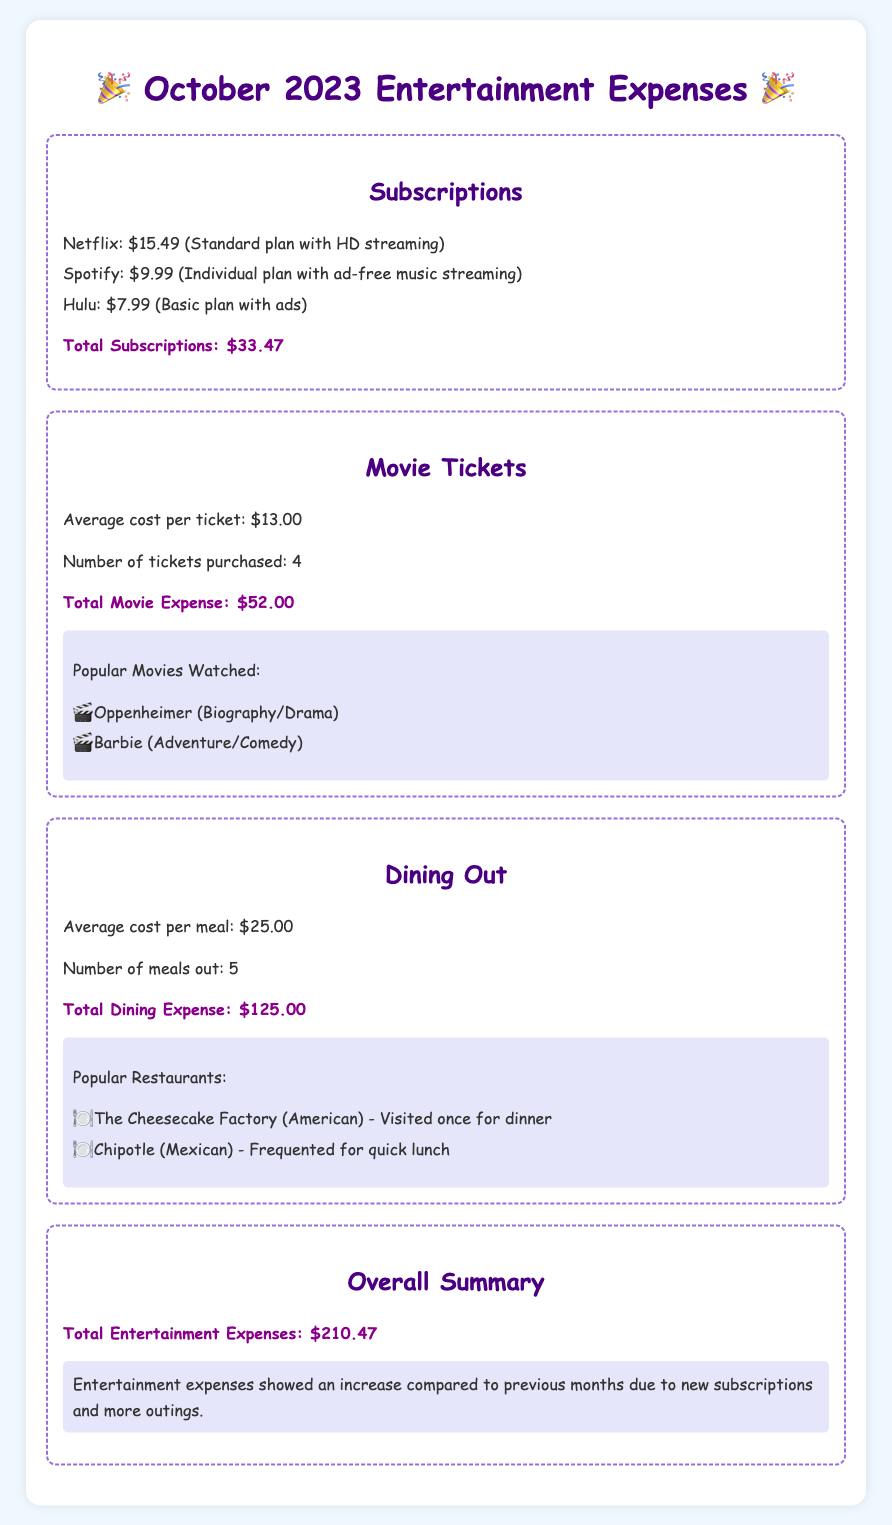What is the total amount spent on subscriptions? The total amount for subscriptions is listed in the document and is $33.47.
Answer: $33.47 How many movie tickets were purchased? The document states that 4 movie tickets were purchased.
Answer: 4 What was the cost of a meal on average? The average cost per meal is specifically mentioned in the dining section as $25.00.
Answer: $25.00 What are the popular movies watched? The document lists "Oppenheimer" and "Barbie" as the popular movies watched.
Answer: Oppenheimer and Barbie What is the total entertainment expense for October 2023? The overall summary section provides the total entertainment expenses, which is $210.47.
Answer: $210.47 How many meals were eaten out? According to the dining section, 5 meals were eaten out.
Answer: 5 Which subscription is the most expensive? The document lists Netflix as the most expensive subscription at $15.49.
Answer: Netflix What type of restaurant is Chipotle? The document categorizes Chipotle as a Mexican restaurant.
Answer: Mexican What indicated an increase in expenses? The document mentions "new subscriptions and more outings" as reasons for increased expenses.
Answer: new subscriptions and more outings 